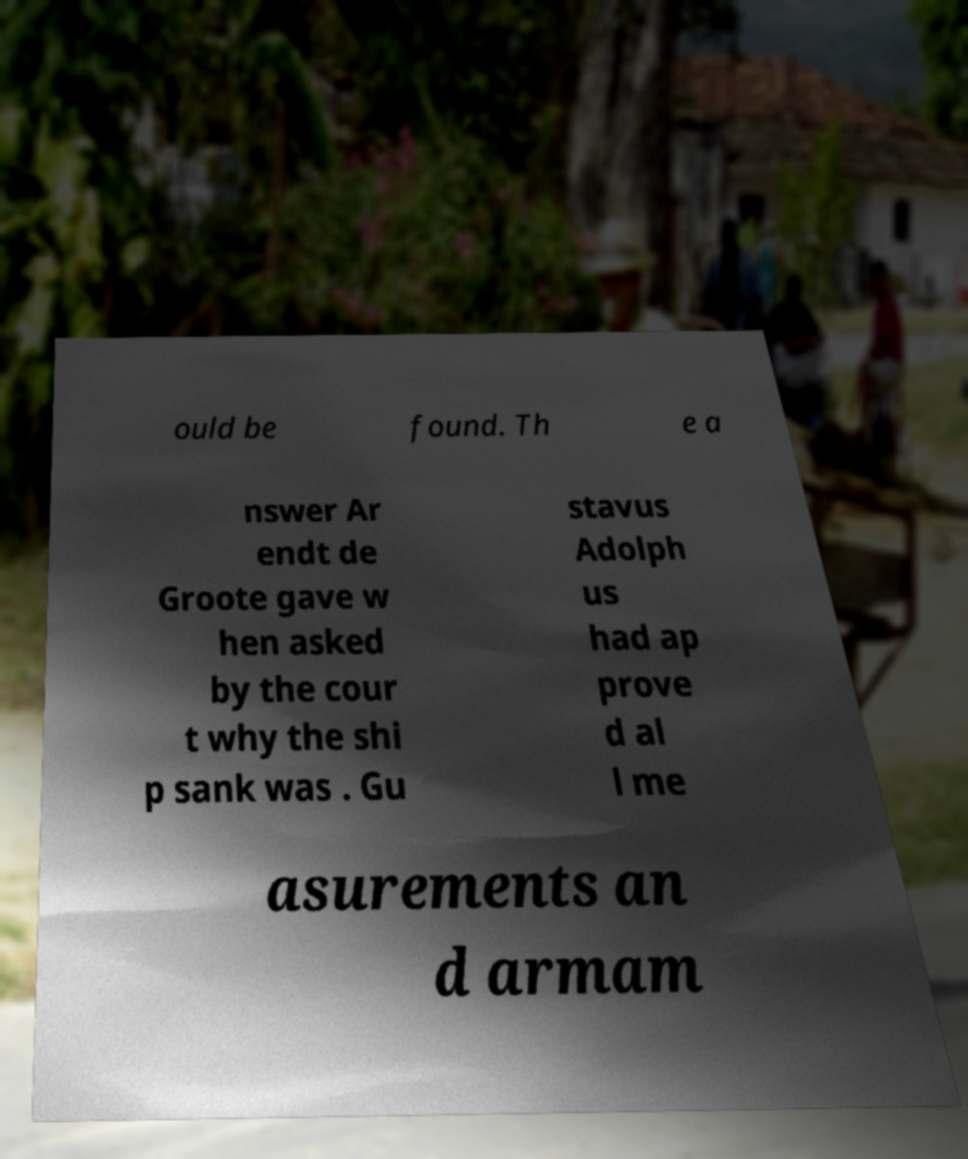I need the written content from this picture converted into text. Can you do that? ould be found. Th e a nswer Ar endt de Groote gave w hen asked by the cour t why the shi p sank was . Gu stavus Adolph us had ap prove d al l me asurements an d armam 